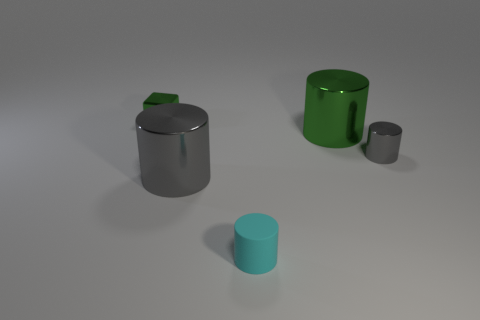Which of the cylinders appears to be the tallest? The green metallic cylinder seems to be the tallest among the cylinders present in the image. Can you describe the finish of the metal surfaces? Certainly, all cylinders appear to have a smooth and reflective surface finish, with varying degrees of sheen likely indicative of different materials or treatments. 